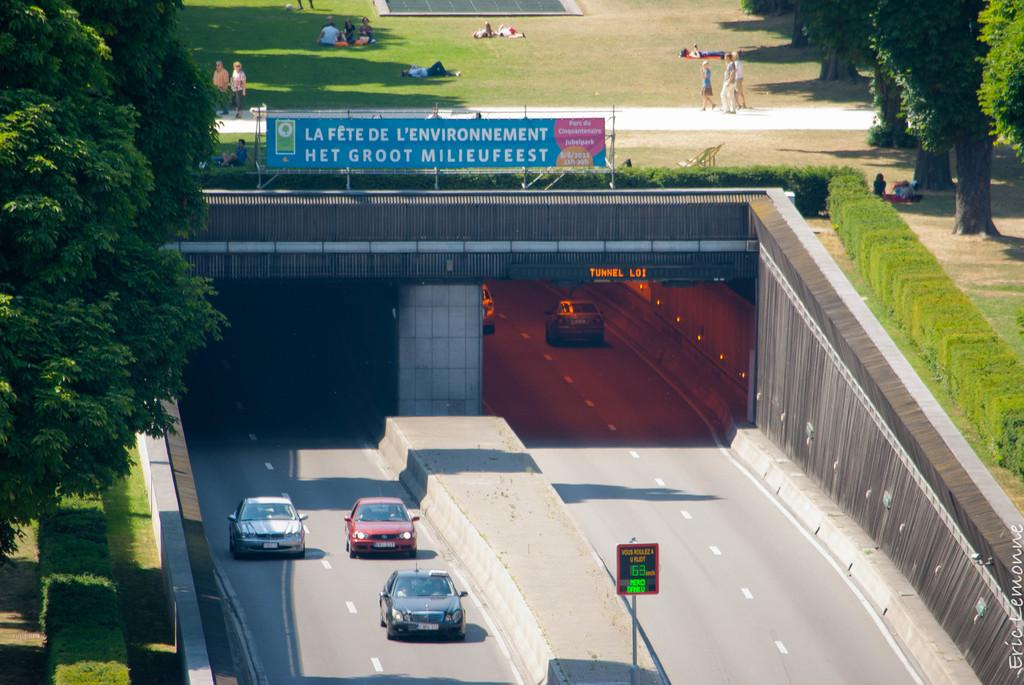What is happening on the road in the image? There are cars moving on the road in the image. What can be seen on either side of the road? There are trees on either side of the road in the image. Where are the people located in the image? The people are visible at the top of the image. How many ladybugs can be seen on the trees in the image? There are no ladybugs visible in the image; only cars, trees, and people are present. 